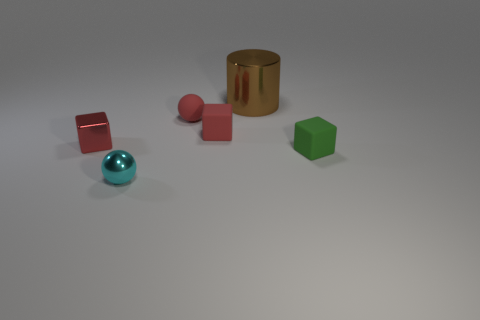What number of other objects are there of the same color as the metallic cube?
Your response must be concise. 2. Are the tiny object in front of the tiny green block and the large object made of the same material?
Your response must be concise. Yes. What material is the small ball that is in front of the green thing?
Your response must be concise. Metal. There is a metallic thing that is behind the small red matte thing that is right of the small matte sphere; what is its size?
Provide a short and direct response. Large. Are there any tiny cyan things that have the same material as the brown cylinder?
Keep it short and to the point. Yes. What is the shape of the metallic thing in front of the tiny object that is on the left side of the small sphere in front of the green thing?
Your response must be concise. Sphere. Does the matte cube that is behind the red metal cube have the same color as the tiny cube left of the small matte sphere?
Provide a short and direct response. Yes. Is there any other thing that has the same size as the red ball?
Keep it short and to the point. Yes. There is a brown cylinder; are there any tiny rubber things left of it?
Ensure brevity in your answer.  Yes. How many other brown metallic things are the same shape as the large brown object?
Your answer should be very brief. 0. 